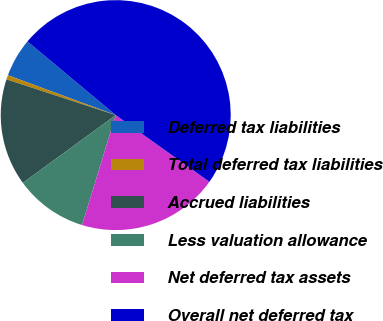Convert chart. <chart><loc_0><loc_0><loc_500><loc_500><pie_chart><fcel>Deferred tax liabilities<fcel>Total deferred tax liabilities<fcel>Accrued liabilities<fcel>Less valuation allowance<fcel>Net deferred tax assets<fcel>Overall net deferred tax<nl><fcel>5.43%<fcel>0.61%<fcel>15.06%<fcel>10.24%<fcel>19.88%<fcel>48.78%<nl></chart> 